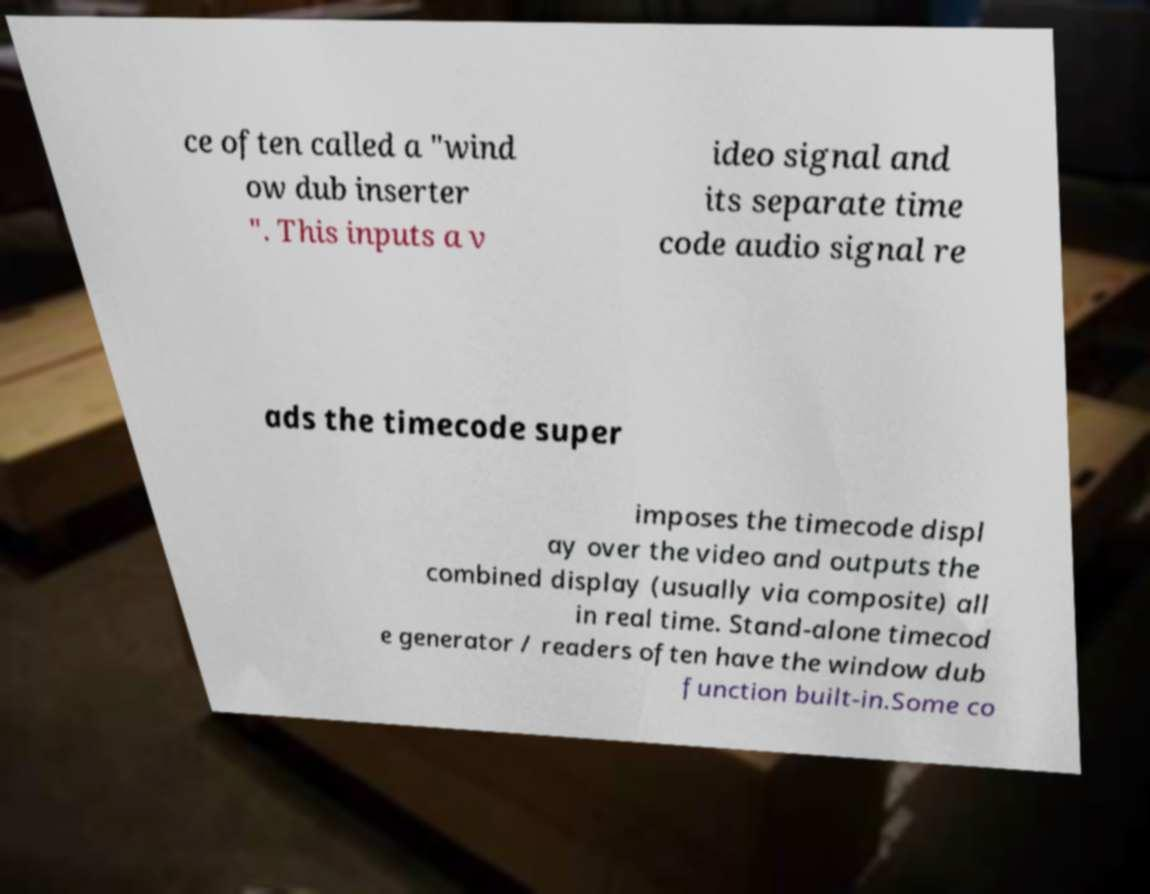Please read and relay the text visible in this image. What does it say? ce often called a "wind ow dub inserter ". This inputs a v ideo signal and its separate time code audio signal re ads the timecode super imposes the timecode displ ay over the video and outputs the combined display (usually via composite) all in real time. Stand-alone timecod e generator / readers often have the window dub function built-in.Some co 